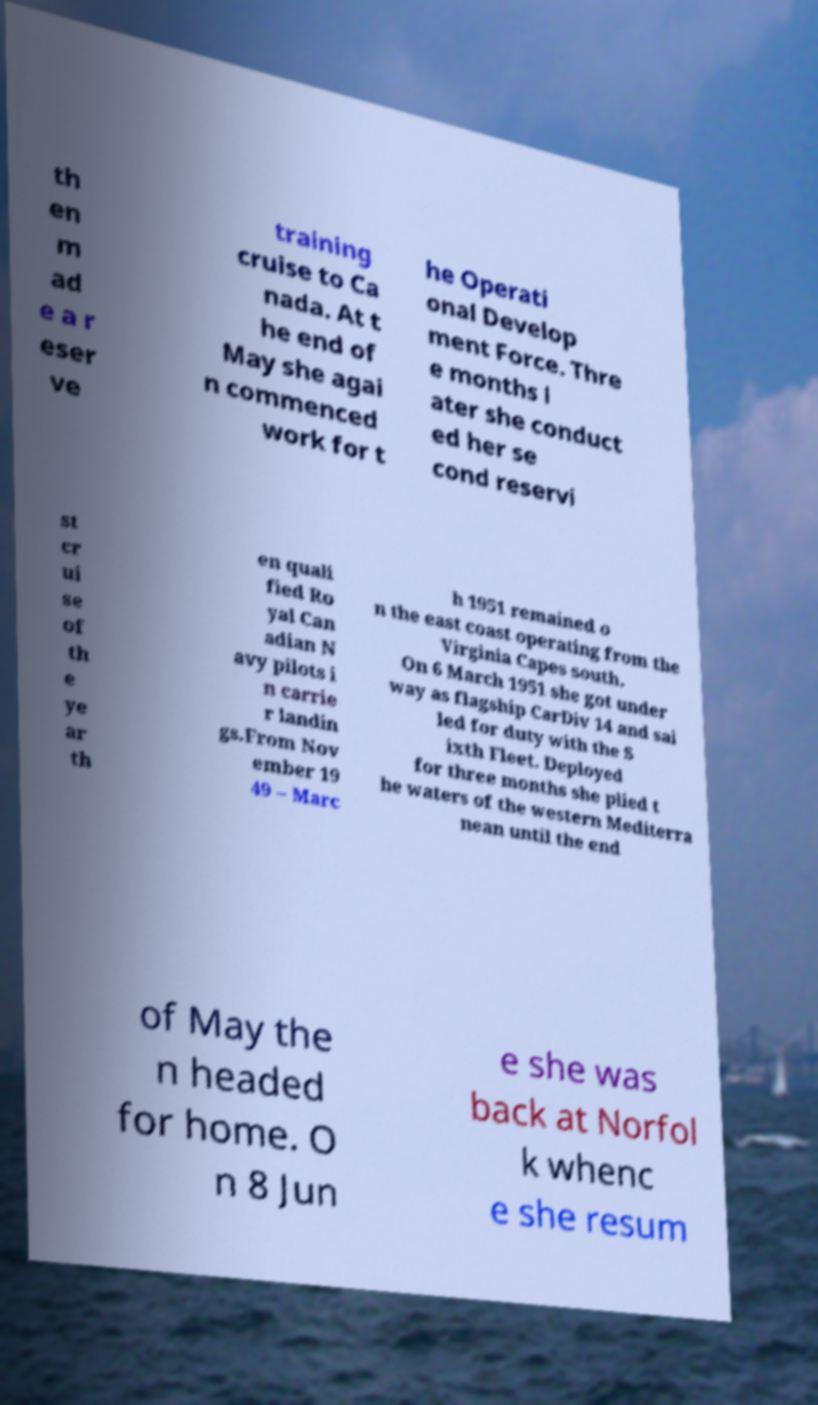Could you extract and type out the text from this image? th en m ad e a r eser ve training cruise to Ca nada. At t he end of May she agai n commenced work for t he Operati onal Develop ment Force. Thre e months l ater she conduct ed her se cond reservi st cr ui se of th e ye ar th en quali fied Ro yal Can adian N avy pilots i n carrie r landin gs.From Nov ember 19 49 – Marc h 1951 remained o n the east coast operating from the Virginia Capes south. On 6 March 1951 she got under way as flagship CarDiv 14 and sai led for duty with the S ixth Fleet. Deployed for three months she plied t he waters of the western Mediterra nean until the end of May the n headed for home. O n 8 Jun e she was back at Norfol k whenc e she resum 